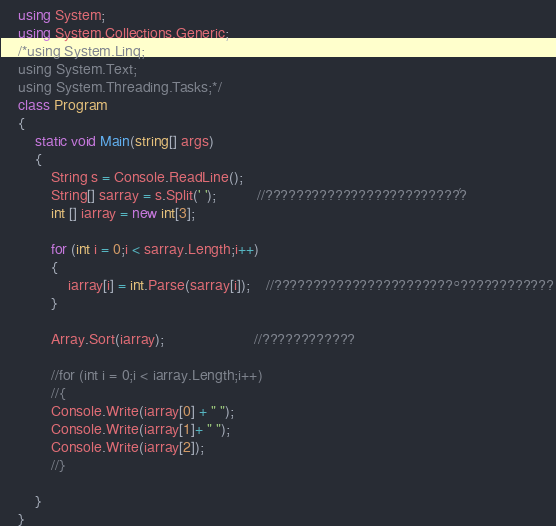<code> <loc_0><loc_0><loc_500><loc_500><_C#_>    using System;
    using System.Collections.Generic;
    /*using System.Linq;
    using System.Text;
    using System.Threading.Tasks;*/
    class Program
    {
        static void Main(string[] args)
        {
            String s = Console.ReadLine();
            String[] sarray = s.Split(' ');          //?????????????????????????´?
            int [] iarray = new int[3];

            for (int i = 0;i < sarray.Length;i++)
            {
                iarray[i] = int.Parse(sarray[i]);    //???????????????????????°????????????
            }

            Array.Sort(iarray);                      //????????????

            //for (int i = 0;i < iarray.Length;i++)
            //{
            Console.Write(iarray[0] + " ");
            Console.Write(iarray[1]+ " ");
            Console.Write(iarray[2]);
            //}
        
        }
    }</code> 